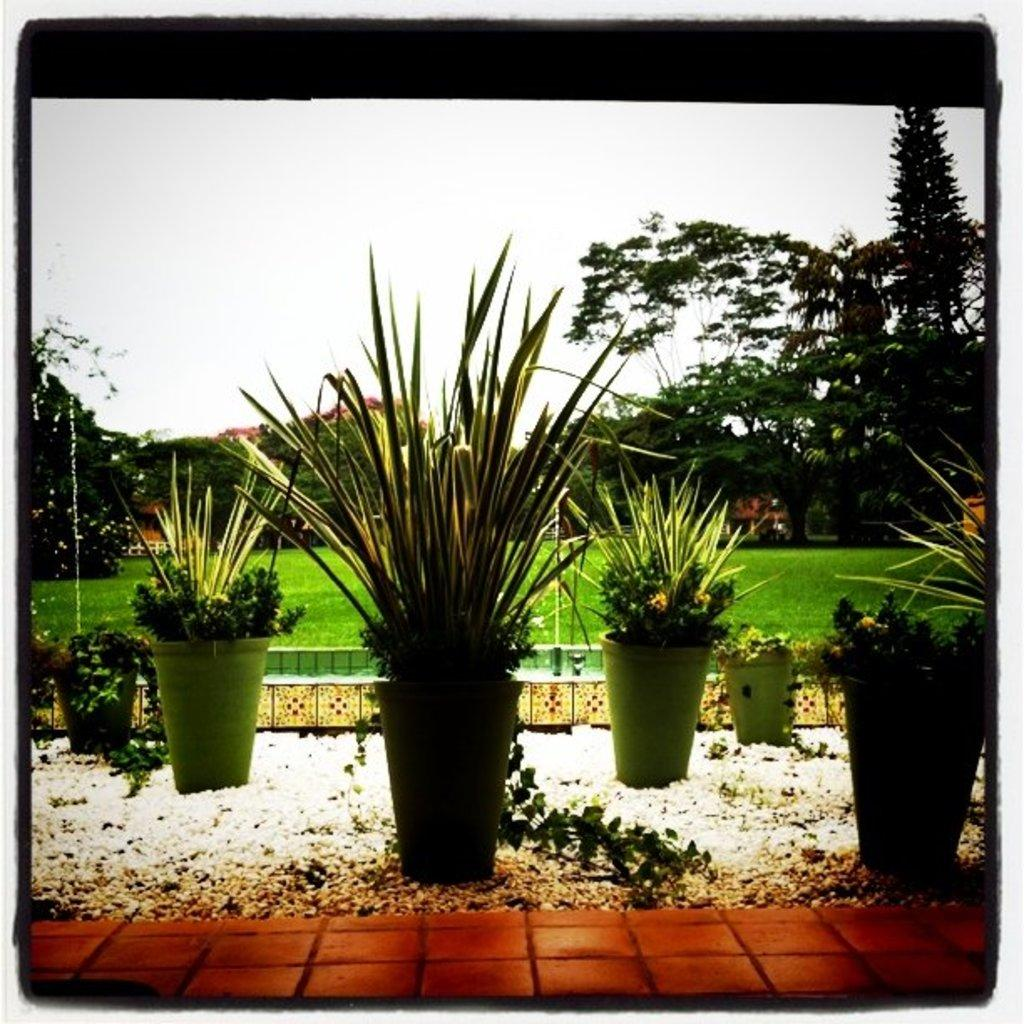What objects are present in the image that contain plants? There are flower pots in the image that contain plants. What type of plants are in the flower pots? The plants in the flower pots are not specified, but they are present in the image. What type of vegetation can be seen in the image besides the plants in the flower pots? There are trees visible in the image. What is visible at the top of the image? The sky is visible at the top of the image. What type of government is depicted in the image? There is no depiction of a government in the image; it features flower pots, plants, trees, and the sky. How many knots are tied in the image? There are no knots present in the image. 